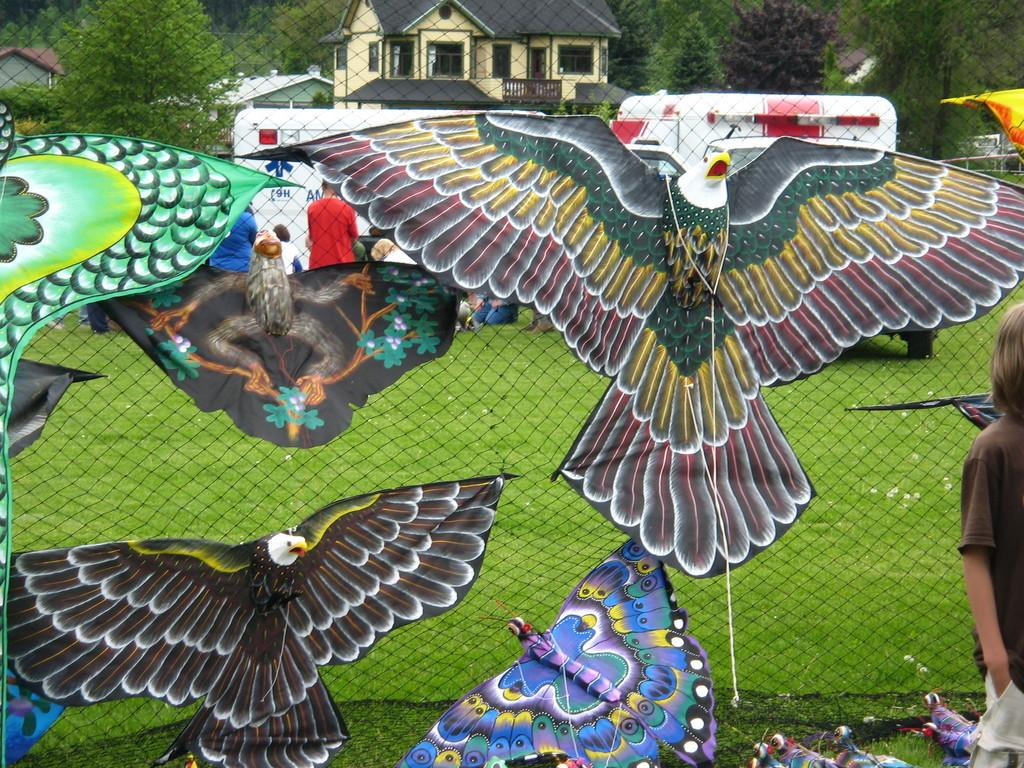What is the main subject of the image? There is a kid standing in the image. What else can be seen in the image besides the kid? There are kites in the image. What is the mesh in the image used for? The mesh is used to provide a view of the surroundings, such as grass, people, vehicles, houses, and trees. What type of joke can be seen hanging from the hook in the image? There is no hook or joke present in the image. What color is the silver object visible through the mesh? There is no silver object visible through the mesh; only grass, people, vehicles, houses, and trees can be seen. 